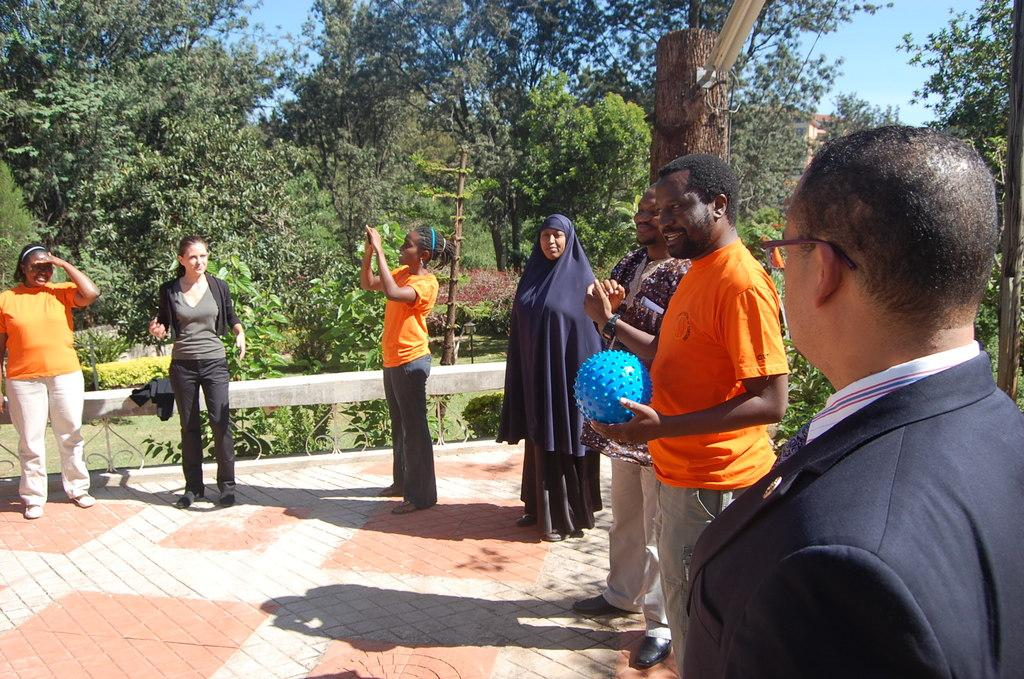What are the people in the image doing? The people in the image are standing on the floor. What is one of the people holding in their hands? One of the people is holding a ball in their hands. What can be seen in the background of the image? Sky, trees, the ground, poles, and bushes are visible in the background of the image. What type of secretary can be seen working in the image? There is no secretary present in the image; it features people standing on the floor and a background with various elements. How many times do the people in the image shake hands? There is no indication of handshakes or any interaction between the people in the image. 